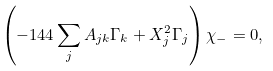Convert formula to latex. <formula><loc_0><loc_0><loc_500><loc_500>\left ( - 1 4 4 \sum _ { j } A _ { j k } \Gamma _ { k } + X ^ { 2 } _ { j } \Gamma _ { j } \right ) \chi _ { - } = 0 ,</formula> 